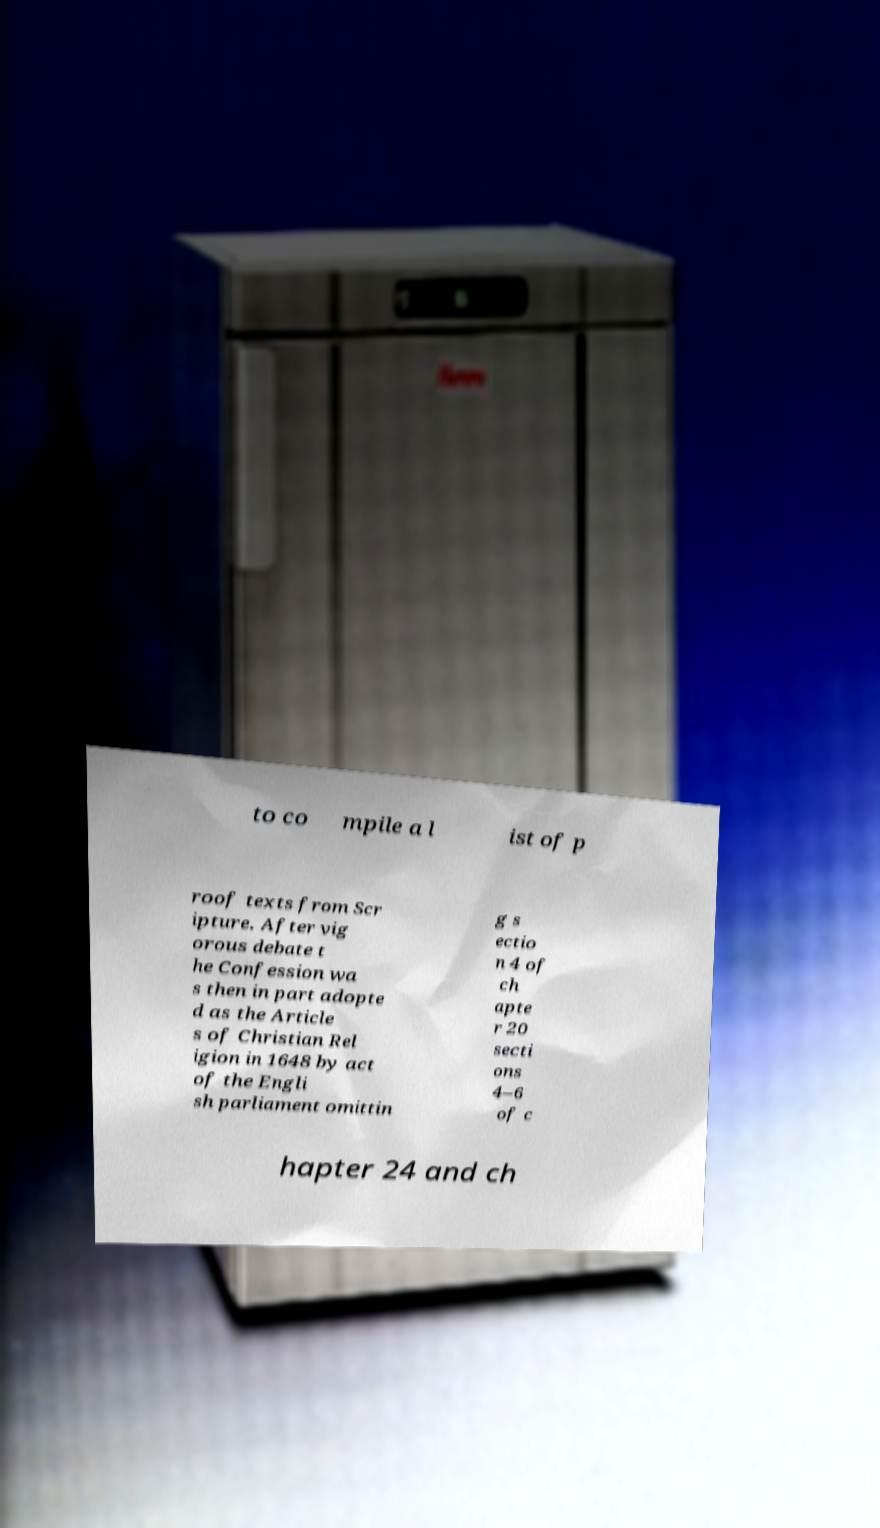Please read and relay the text visible in this image. What does it say? to co mpile a l ist of p roof texts from Scr ipture. After vig orous debate t he Confession wa s then in part adopte d as the Article s of Christian Rel igion in 1648 by act of the Engli sh parliament omittin g s ectio n 4 of ch apte r 20 secti ons 4–6 of c hapter 24 and ch 